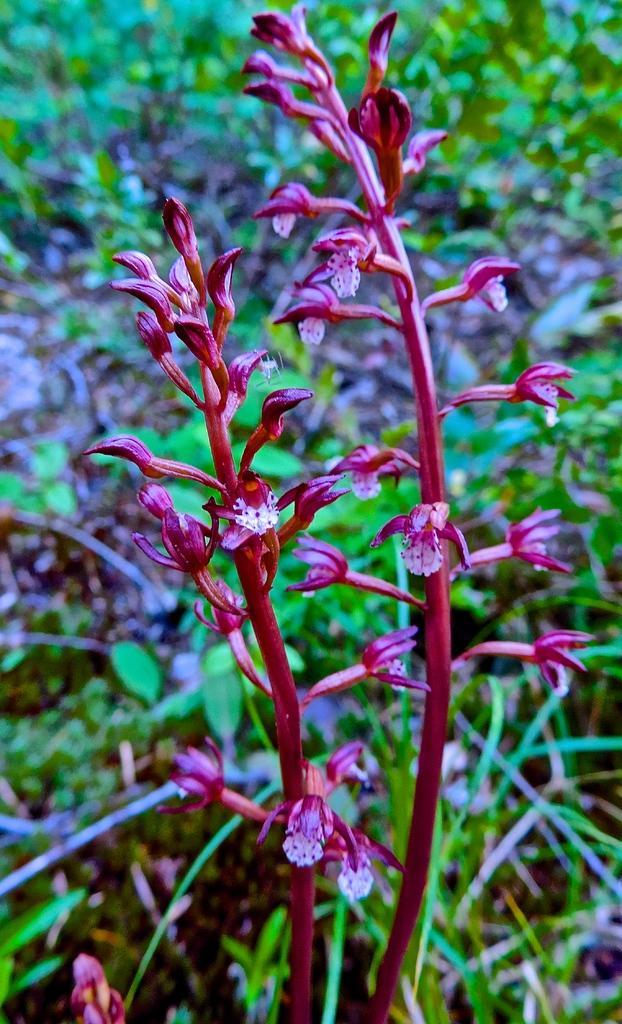Describe this image in one or two sentences. In this image we can see some flowers, plants, and the background is blurred. 